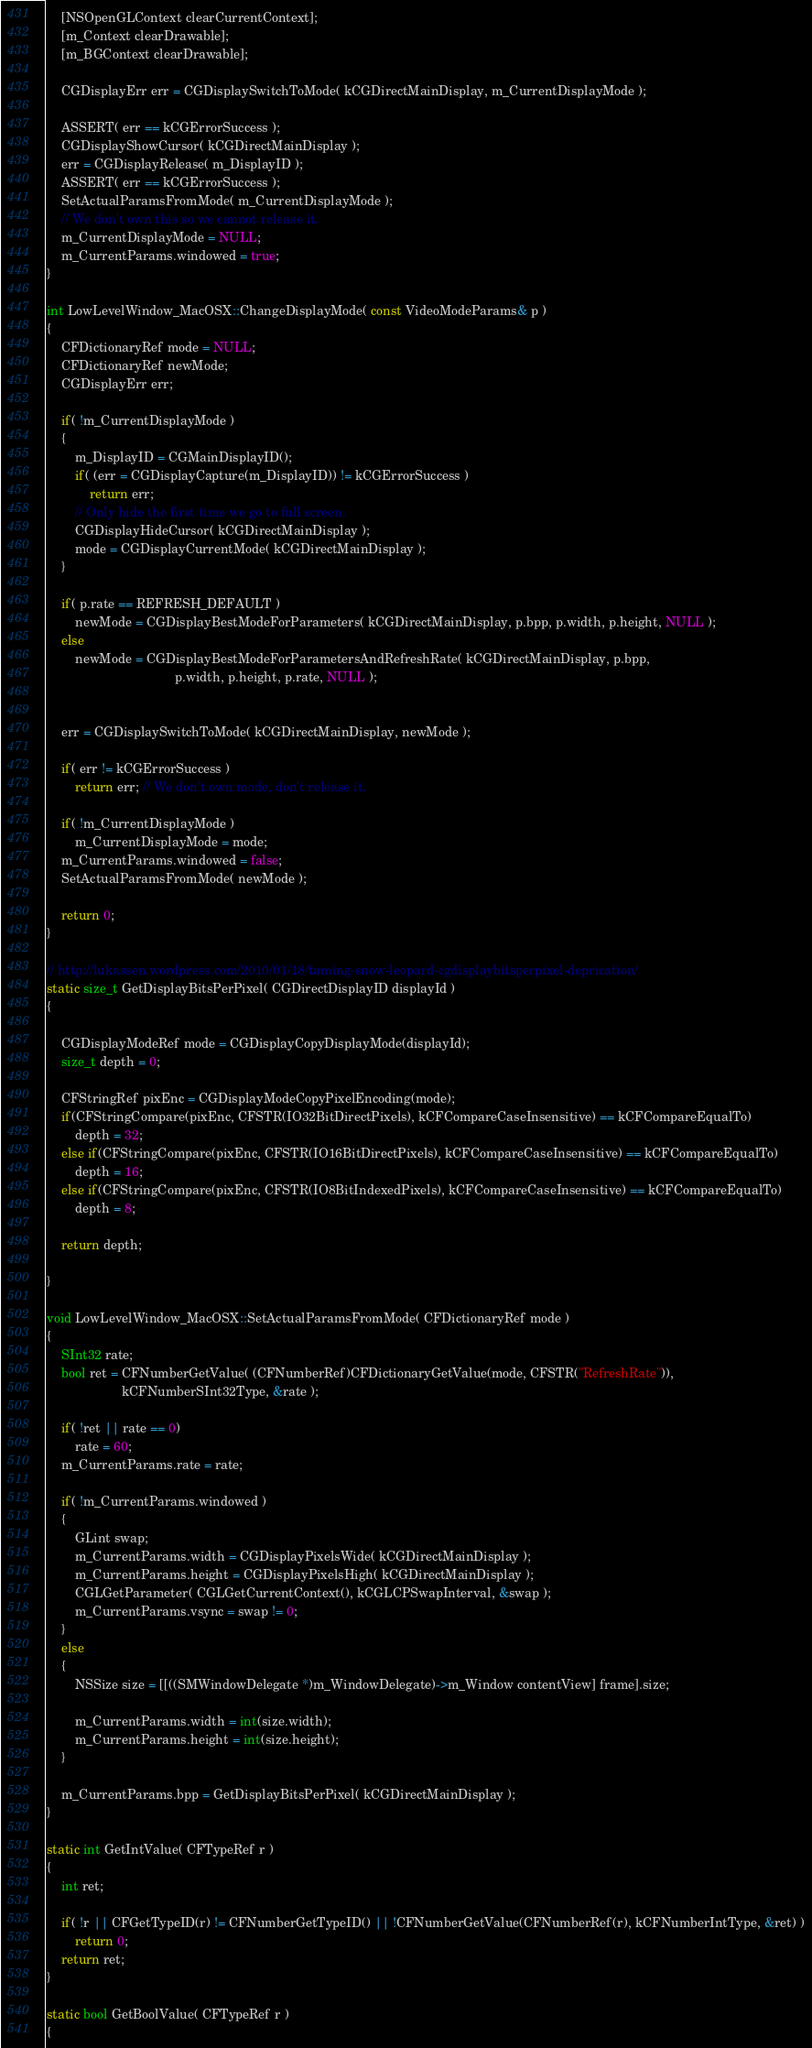<code> <loc_0><loc_0><loc_500><loc_500><_ObjectiveC_>	[NSOpenGLContext clearCurrentContext];
	[m_Context clearDrawable];
	[m_BGContext clearDrawable];
	
	CGDisplayErr err = CGDisplaySwitchToMode( kCGDirectMainDisplay, m_CurrentDisplayMode );
	
	ASSERT( err == kCGErrorSuccess );
	CGDisplayShowCursor( kCGDirectMainDisplay );
	err = CGDisplayRelease( m_DisplayID );
	ASSERT( err == kCGErrorSuccess );
	SetActualParamsFromMode( m_CurrentDisplayMode );
	// We don't own this so we cannot release it.
	m_CurrentDisplayMode = NULL;
	m_CurrentParams.windowed = true;
}

int LowLevelWindow_MacOSX::ChangeDisplayMode( const VideoModeParams& p )
{	
	CFDictionaryRef mode = NULL;
	CFDictionaryRef newMode;
	CGDisplayErr err;
	
	if( !m_CurrentDisplayMode )
	{
		m_DisplayID = CGMainDisplayID();
		if( (err = CGDisplayCapture(m_DisplayID)) != kCGErrorSuccess )
			return err;
		// Only hide the first time we go to full screen.
		CGDisplayHideCursor( kCGDirectMainDisplay );	
		mode = CGDisplayCurrentMode( kCGDirectMainDisplay );
	}
	
	if( p.rate == REFRESH_DEFAULT )
		newMode = CGDisplayBestModeForParameters( kCGDirectMainDisplay, p.bpp, p.width, p.height, NULL );
	else
		newMode = CGDisplayBestModeForParametersAndRefreshRate( kCGDirectMainDisplay, p.bpp,
									p.width, p.height, p.rate, NULL );
	
	
	err = CGDisplaySwitchToMode( kCGDirectMainDisplay, newMode );
	
	if( err != kCGErrorSuccess )
		return err; // We don't own mode, don't release it.
	
	if( !m_CurrentDisplayMode )
		m_CurrentDisplayMode = mode;
	m_CurrentParams.windowed = false;
	SetActualParamsFromMode( newMode );
	
	return 0;
}

// http://lukassen.wordpress.com/2010/01/18/taming-snow-leopard-cgdisplaybitsperpixel-deprication/
static size_t GetDisplayBitsPerPixel( CGDirectDisplayID displayId )
{
	
	CGDisplayModeRef mode = CGDisplayCopyDisplayMode(displayId);
	size_t depth = 0;
	
	CFStringRef pixEnc = CGDisplayModeCopyPixelEncoding(mode);
	if(CFStringCompare(pixEnc, CFSTR(IO32BitDirectPixels), kCFCompareCaseInsensitive) == kCFCompareEqualTo)
		depth = 32;
	else if(CFStringCompare(pixEnc, CFSTR(IO16BitDirectPixels), kCFCompareCaseInsensitive) == kCFCompareEqualTo)
		depth = 16;
	else if(CFStringCompare(pixEnc, CFSTR(IO8BitIndexedPixels), kCFCompareCaseInsensitive) == kCFCompareEqualTo)
		depth = 8;
	
	return depth;

}

void LowLevelWindow_MacOSX::SetActualParamsFromMode( CFDictionaryRef mode )
{
	SInt32 rate;
	bool ret = CFNumberGetValue( (CFNumberRef)CFDictionaryGetValue(mode, CFSTR("RefreshRate")),
				     kCFNumberSInt32Type, &rate );
	
	if( !ret || rate == 0)
		rate = 60;
	m_CurrentParams.rate = rate;

	if( !m_CurrentParams.windowed )
	{
		GLint swap;
		m_CurrentParams.width = CGDisplayPixelsWide( kCGDirectMainDisplay );
		m_CurrentParams.height = CGDisplayPixelsHigh( kCGDirectMainDisplay );
		CGLGetParameter( CGLGetCurrentContext(), kCGLCPSwapInterval, &swap );
		m_CurrentParams.vsync = swap != 0;
	}
	else
	{
		NSSize size = [[((SMWindowDelegate *)m_WindowDelegate)->m_Window contentView] frame].size;
		
		m_CurrentParams.width = int(size.width);
		m_CurrentParams.height = int(size.height);
	}

	m_CurrentParams.bpp = GetDisplayBitsPerPixel( kCGDirectMainDisplay );
}

static int GetIntValue( CFTypeRef r )
{
	int ret;
	
	if( !r || CFGetTypeID(r) != CFNumberGetTypeID() || !CFNumberGetValue(CFNumberRef(r), kCFNumberIntType, &ret) )
		return 0;
	return ret;
}

static bool GetBoolValue( CFTypeRef r )
{</code> 